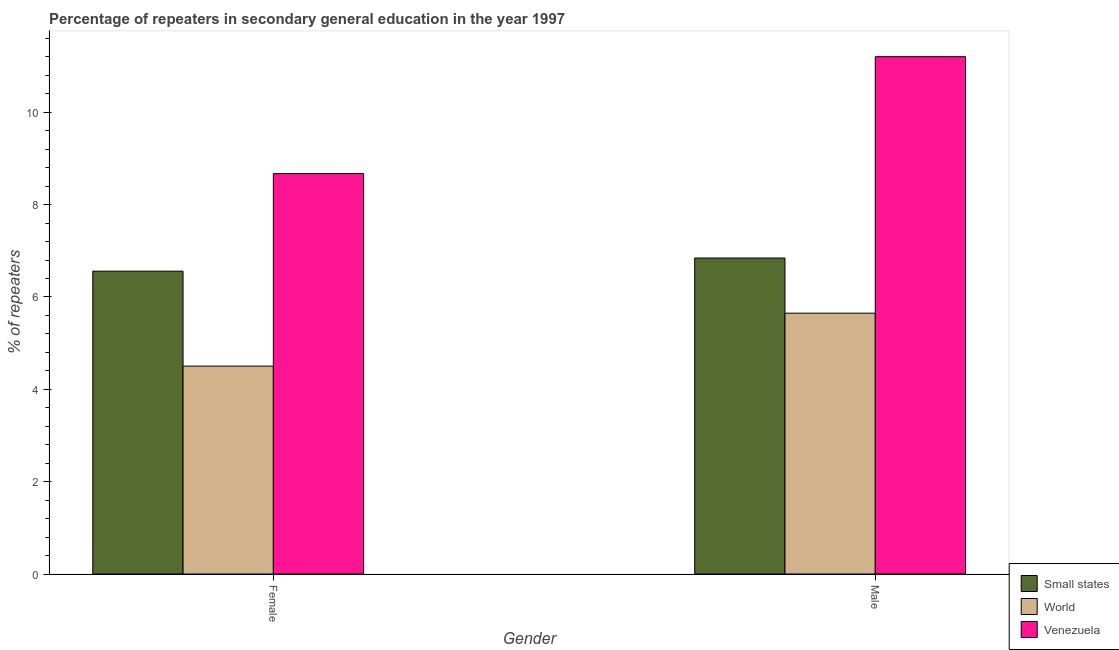How many different coloured bars are there?
Keep it short and to the point. 3. How many groups of bars are there?
Your response must be concise. 2. How many bars are there on the 2nd tick from the left?
Your answer should be compact. 3. How many bars are there on the 1st tick from the right?
Your answer should be very brief. 3. What is the label of the 1st group of bars from the left?
Your response must be concise. Female. What is the percentage of female repeaters in World?
Your response must be concise. 4.5. Across all countries, what is the maximum percentage of female repeaters?
Your answer should be compact. 8.67. Across all countries, what is the minimum percentage of male repeaters?
Offer a very short reply. 5.65. In which country was the percentage of female repeaters maximum?
Make the answer very short. Venezuela. In which country was the percentage of male repeaters minimum?
Ensure brevity in your answer.  World. What is the total percentage of male repeaters in the graph?
Offer a terse response. 23.69. What is the difference between the percentage of female repeaters in Venezuela and that in Small states?
Offer a terse response. 2.11. What is the difference between the percentage of male repeaters in World and the percentage of female repeaters in Venezuela?
Offer a very short reply. -3.02. What is the average percentage of female repeaters per country?
Keep it short and to the point. 6.58. What is the difference between the percentage of female repeaters and percentage of male repeaters in World?
Offer a terse response. -1.15. What is the ratio of the percentage of male repeaters in Small states to that in Venezuela?
Offer a very short reply. 0.61. Is the percentage of female repeaters in Venezuela less than that in Small states?
Your answer should be very brief. No. What does the 3rd bar from the left in Male represents?
Keep it short and to the point. Venezuela. What does the 3rd bar from the right in Male represents?
Provide a short and direct response. Small states. How many bars are there?
Offer a very short reply. 6. Are all the bars in the graph horizontal?
Provide a succinct answer. No. How many countries are there in the graph?
Your answer should be compact. 3. How many legend labels are there?
Offer a very short reply. 3. How are the legend labels stacked?
Your answer should be very brief. Vertical. What is the title of the graph?
Ensure brevity in your answer.  Percentage of repeaters in secondary general education in the year 1997. What is the label or title of the Y-axis?
Ensure brevity in your answer.  % of repeaters. What is the % of repeaters in Small states in Female?
Keep it short and to the point. 6.56. What is the % of repeaters of World in Female?
Your response must be concise. 4.5. What is the % of repeaters of Venezuela in Female?
Your answer should be compact. 8.67. What is the % of repeaters in Small states in Male?
Provide a succinct answer. 6.84. What is the % of repeaters in World in Male?
Your response must be concise. 5.65. What is the % of repeaters of Venezuela in Male?
Your answer should be compact. 11.2. Across all Gender, what is the maximum % of repeaters of Small states?
Offer a very short reply. 6.84. Across all Gender, what is the maximum % of repeaters in World?
Make the answer very short. 5.65. Across all Gender, what is the maximum % of repeaters in Venezuela?
Ensure brevity in your answer.  11.2. Across all Gender, what is the minimum % of repeaters in Small states?
Your answer should be very brief. 6.56. Across all Gender, what is the minimum % of repeaters in World?
Give a very brief answer. 4.5. Across all Gender, what is the minimum % of repeaters of Venezuela?
Offer a terse response. 8.67. What is the total % of repeaters in Small states in the graph?
Make the answer very short. 13.4. What is the total % of repeaters in World in the graph?
Offer a very short reply. 10.15. What is the total % of repeaters of Venezuela in the graph?
Provide a succinct answer. 19.87. What is the difference between the % of repeaters in Small states in Female and that in Male?
Your answer should be compact. -0.28. What is the difference between the % of repeaters of World in Female and that in Male?
Your answer should be very brief. -1.15. What is the difference between the % of repeaters of Venezuela in Female and that in Male?
Ensure brevity in your answer.  -2.53. What is the difference between the % of repeaters in Small states in Female and the % of repeaters in World in Male?
Keep it short and to the point. 0.91. What is the difference between the % of repeaters in Small states in Female and the % of repeaters in Venezuela in Male?
Make the answer very short. -4.64. What is the difference between the % of repeaters of World in Female and the % of repeaters of Venezuela in Male?
Offer a very short reply. -6.7. What is the average % of repeaters of Small states per Gender?
Your answer should be compact. 6.7. What is the average % of repeaters in World per Gender?
Offer a terse response. 5.08. What is the average % of repeaters of Venezuela per Gender?
Keep it short and to the point. 9.94. What is the difference between the % of repeaters in Small states and % of repeaters in World in Female?
Your answer should be compact. 2.06. What is the difference between the % of repeaters in Small states and % of repeaters in Venezuela in Female?
Your answer should be very brief. -2.11. What is the difference between the % of repeaters in World and % of repeaters in Venezuela in Female?
Your response must be concise. -4.17. What is the difference between the % of repeaters of Small states and % of repeaters of World in Male?
Ensure brevity in your answer.  1.19. What is the difference between the % of repeaters in Small states and % of repeaters in Venezuela in Male?
Keep it short and to the point. -4.36. What is the difference between the % of repeaters in World and % of repeaters in Venezuela in Male?
Provide a short and direct response. -5.55. What is the ratio of the % of repeaters in Small states in Female to that in Male?
Your answer should be very brief. 0.96. What is the ratio of the % of repeaters of World in Female to that in Male?
Offer a terse response. 0.8. What is the ratio of the % of repeaters of Venezuela in Female to that in Male?
Provide a succinct answer. 0.77. What is the difference between the highest and the second highest % of repeaters in Small states?
Give a very brief answer. 0.28. What is the difference between the highest and the second highest % of repeaters in World?
Offer a very short reply. 1.15. What is the difference between the highest and the second highest % of repeaters in Venezuela?
Make the answer very short. 2.53. What is the difference between the highest and the lowest % of repeaters of Small states?
Offer a very short reply. 0.28. What is the difference between the highest and the lowest % of repeaters of World?
Offer a very short reply. 1.15. What is the difference between the highest and the lowest % of repeaters in Venezuela?
Make the answer very short. 2.53. 